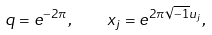<formula> <loc_0><loc_0><loc_500><loc_500>q = e ^ { - 2 \pi } , \quad x _ { j } = e ^ { 2 \pi \sqrt { - 1 } u _ { j } } ,</formula> 